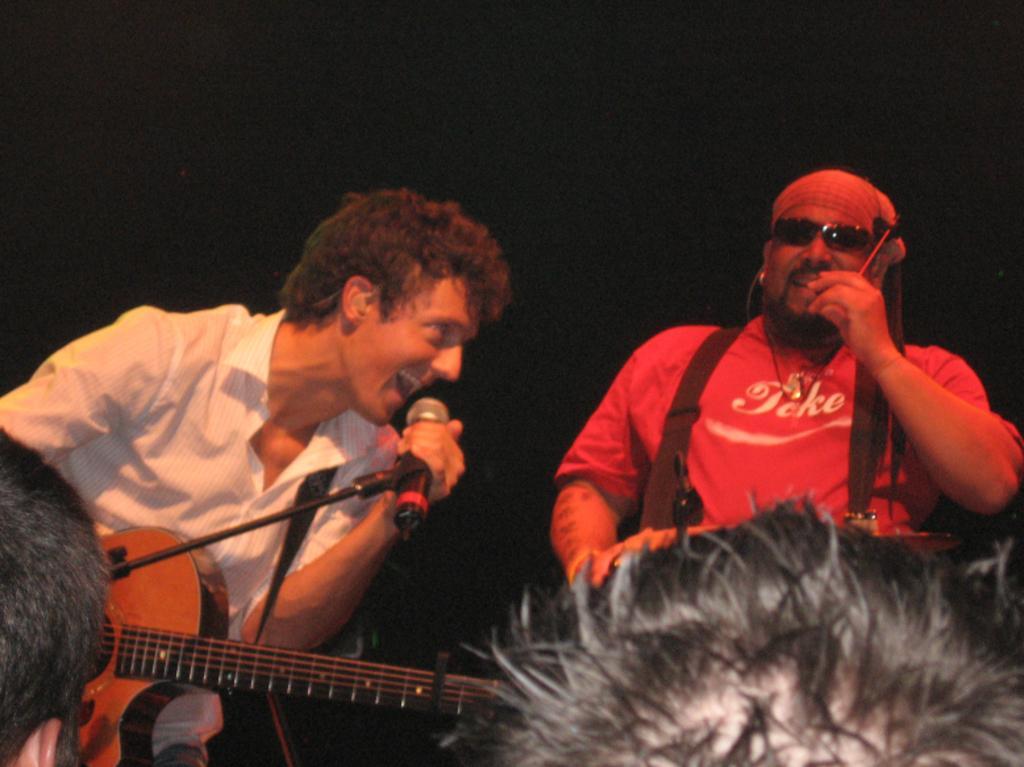Describe this image in one or two sentences. There are two members in this picture. One guy is playing a guitar in his hands and singing in front of a mic and a stand. Another guy is singing. He is wearing spectacles. In the background there is dark. 